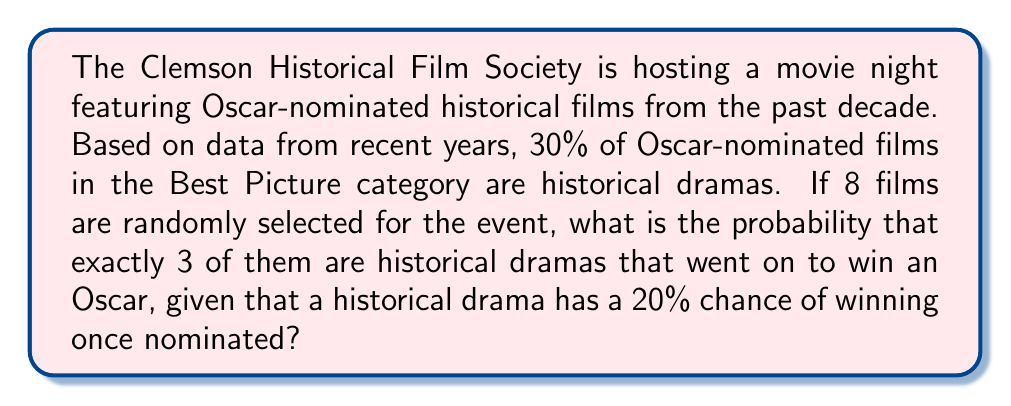Provide a solution to this math problem. To solve this problem, we'll use the binomial probability distribution, as we're dealing with a fixed number of independent trials (selecting 8 films) with two possible outcomes for each trial (historical drama that won an Oscar or not).

Let's break it down step-by-step:

1. Define our variables:
   $n$ = number of films selected = 8
   $k$ = number of historical dramas that won an Oscar = 3
   $p$ = probability of selecting a historical drama that won an Oscar

2. Calculate $p$:
   $p = P(\text{Historical Drama}) \times P(\text{Winning Oscar | Historical Drama})$
   $p = 0.30 \times 0.20 = 0.06$

3. Use the binomial probability formula:

   $$P(X = k) = \binom{n}{k} p^k (1-p)^{n-k}$$

   Where $\binom{n}{k}$ is the binomial coefficient, calculated as:

   $$\binom{n}{k} = \frac{n!}{k!(n-k)!}$$

4. Plug in our values:

   $$P(X = 3) = \binom{8}{3} (0.06)^3 (1-0.06)^{8-3}$$

5. Calculate the binomial coefficient:

   $$\binom{8}{3} = \frac{8!}{3!(8-3)!} = \frac{8!}{3!5!} = 56$$

6. Solve the equation:

   $$P(X = 3) = 56 \times (0.06)^3 \times (0.94)^5$$
   $$= 56 \times 0.000216 \times 0.7339$$
   $$= 0.008883$$

Therefore, the probability of selecting exactly 3 historical dramas that won an Oscar out of 8 randomly selected films is approximately 0.008883 or 0.8883%.
Answer: $0.008883$ or $0.8883\%$ 